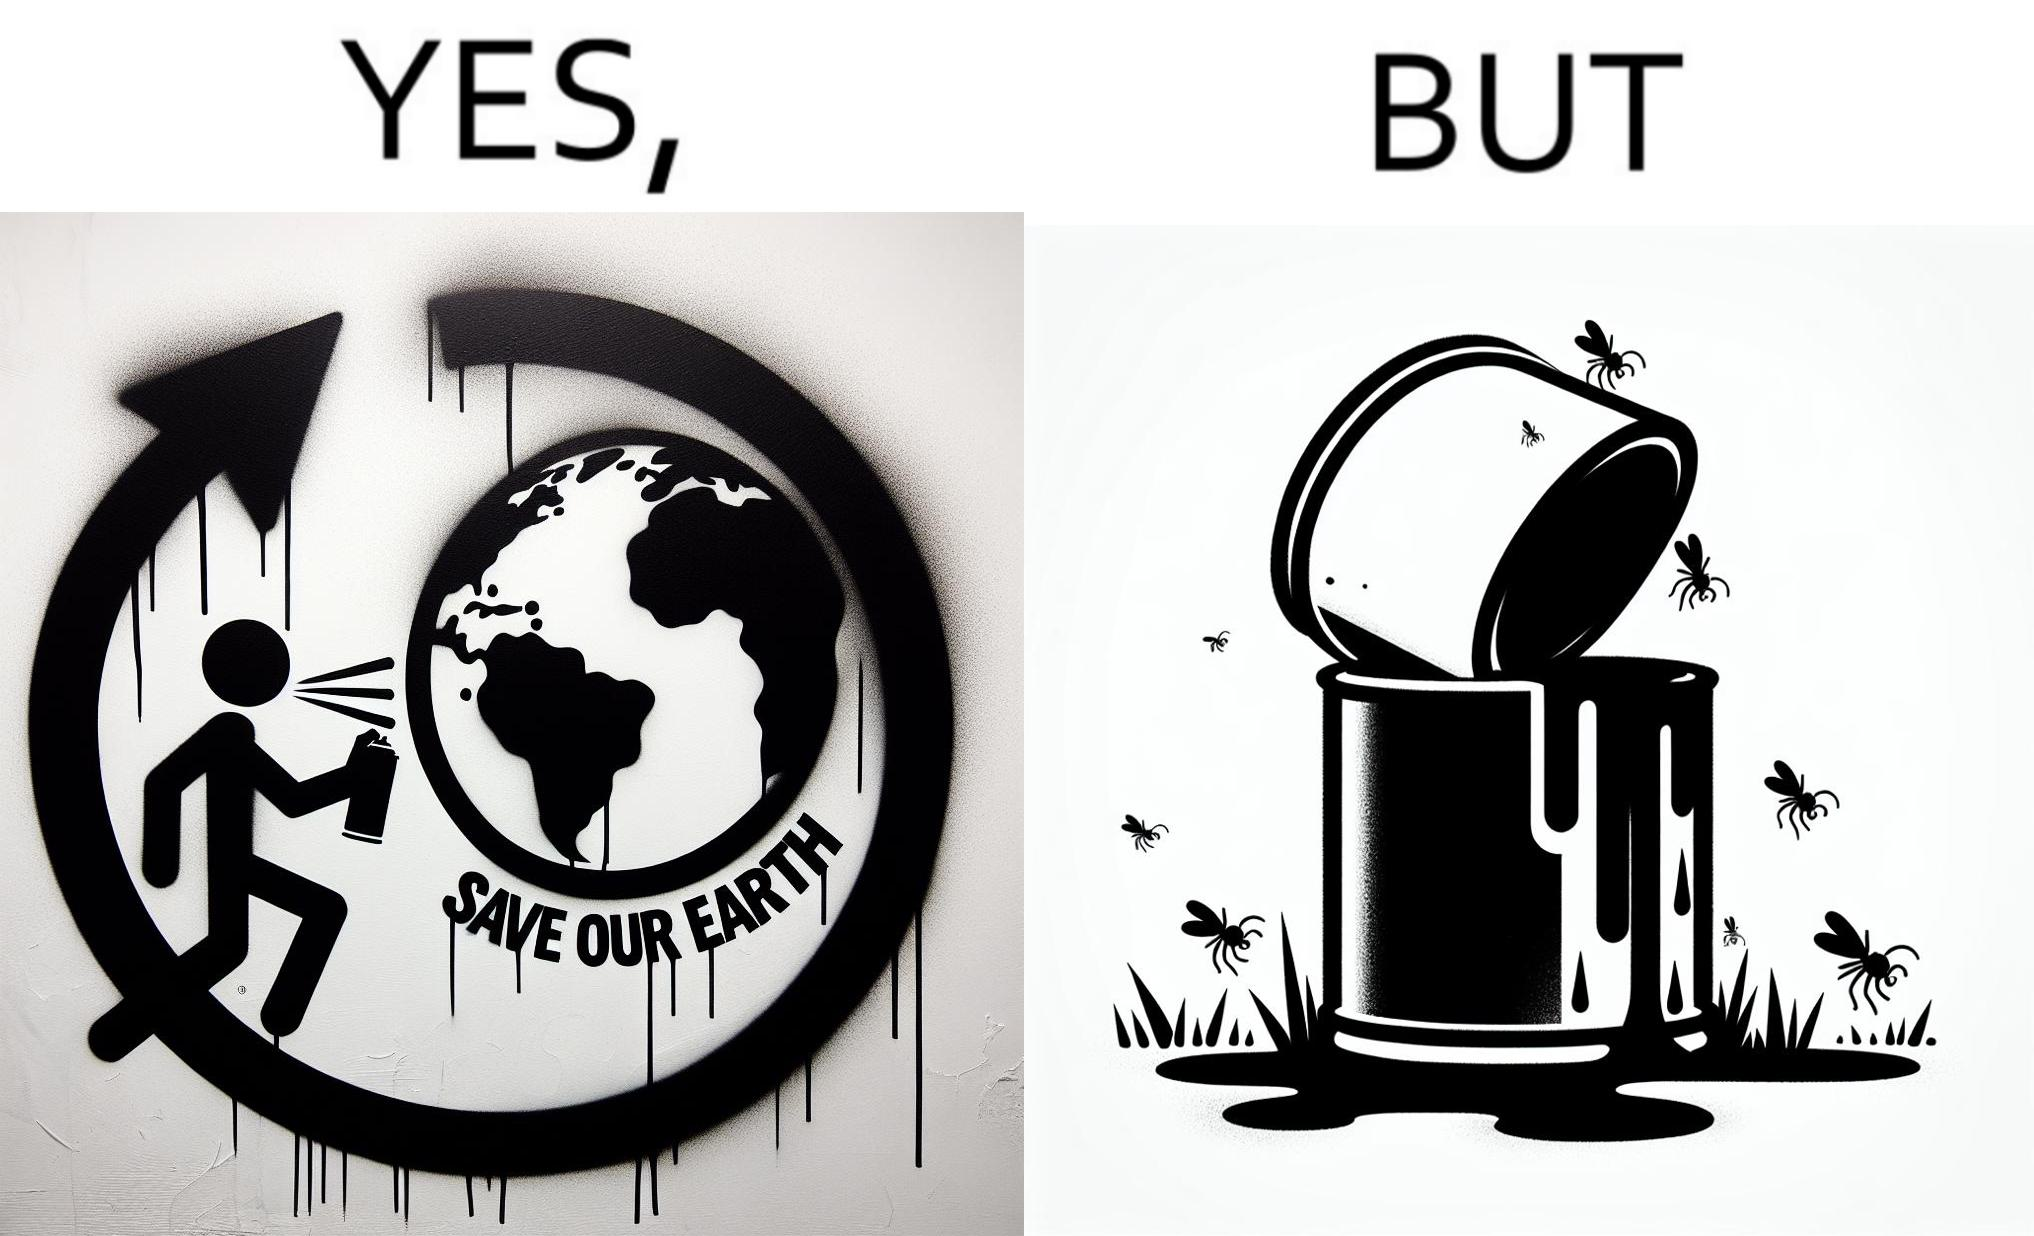What does this image depict? The image is ironical, as the cans of paint used to make graffiti on the theme "Save the Earth" seems to be destroying the Earth when it overflows on the grass, as it is harmful for the flora and fauna, as can be seen from the dying insects. 